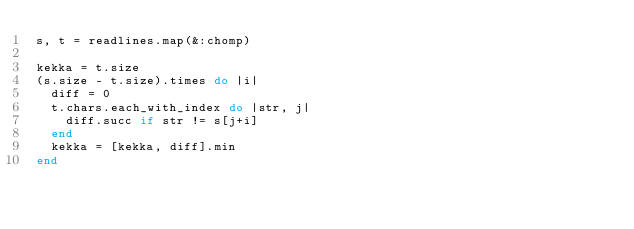Convert code to text. <code><loc_0><loc_0><loc_500><loc_500><_Ruby_>s, t = readlines.map(&:chomp)

kekka = t.size
(s.size - t.size).times do |i|
  diff = 0
  t.chars.each_with_index do |str, j|
	diff.succ if str != s[j+i]
  end
  kekka = [kekka, diff].min
end</code> 